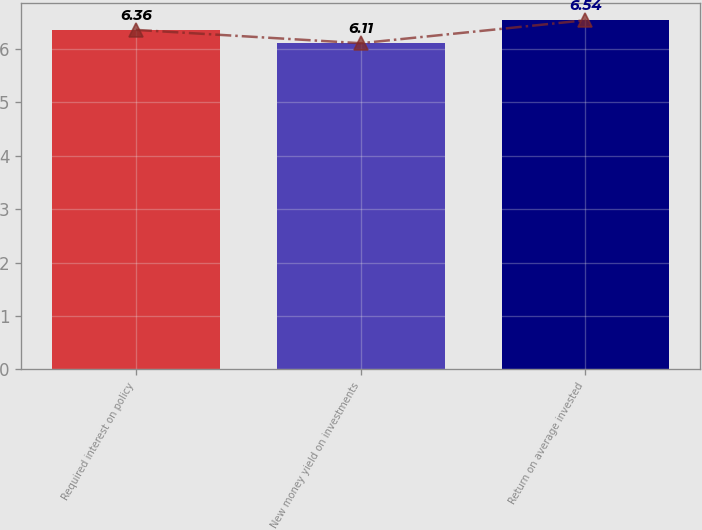<chart> <loc_0><loc_0><loc_500><loc_500><bar_chart><fcel>Required interest on policy<fcel>New money yield on investments<fcel>Return on average invested<nl><fcel>6.36<fcel>6.11<fcel>6.54<nl></chart> 